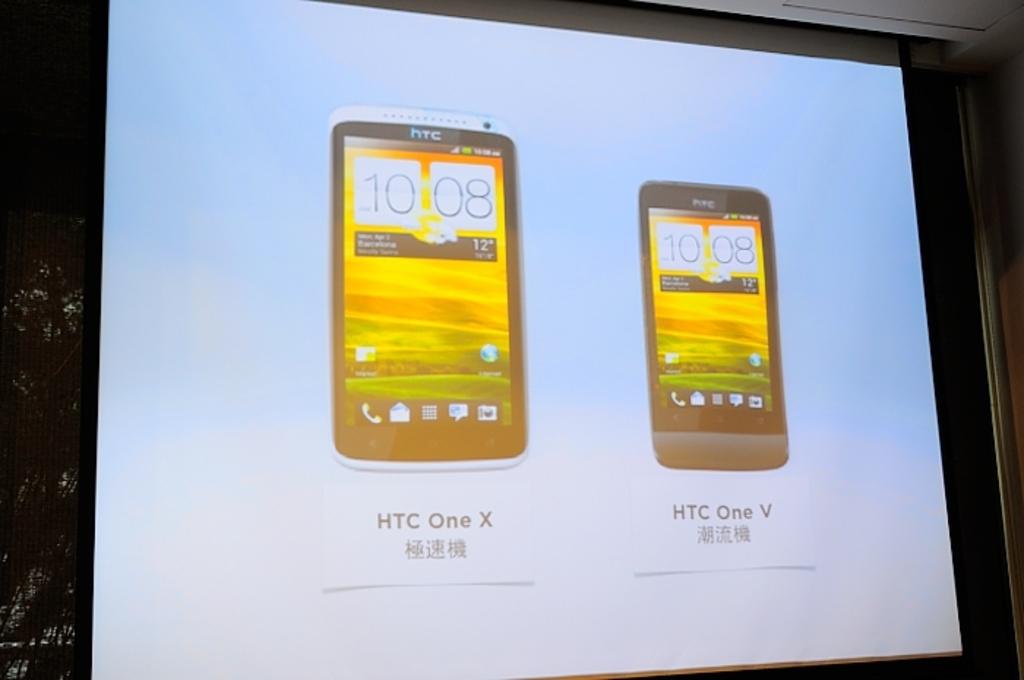Which htc model is more powerful?
Your answer should be compact. Htc one x. What is the left model of phone?
Offer a very short reply. Htc one x. 